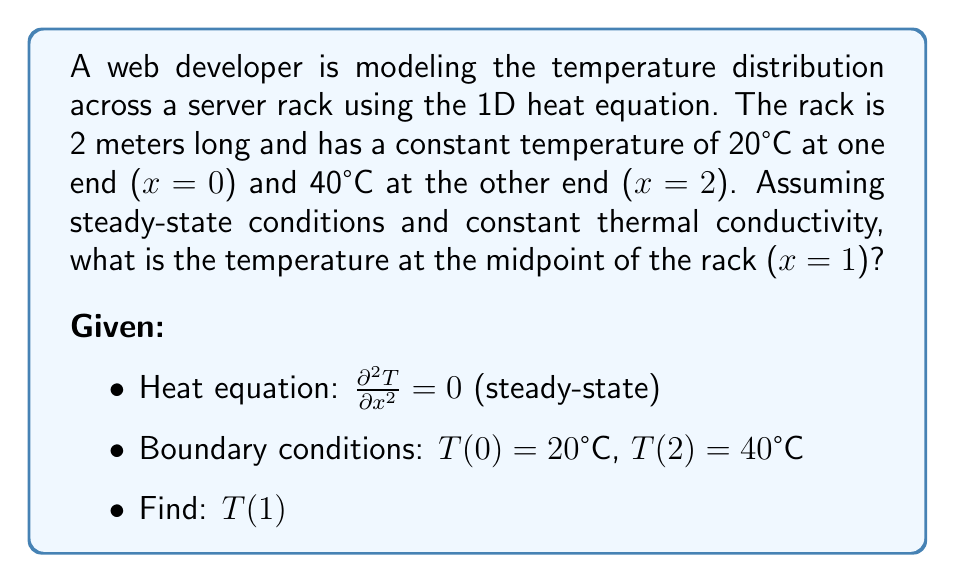Help me with this question. To solve this problem, we'll follow these steps:

1) The general solution to the steady-state heat equation $\frac{\partial^2 T}{\partial x^2} = 0$ is:

   $$T(x) = Ax + B$$

   where A and B are constants we need to determine.

2) Apply the boundary conditions:
   At x = 0: $T(0) = 20 = A(0) + B$, so $B = 20$
   At x = 2: $T(2) = 40 = A(2) + 20$

3) Solve for A:
   $$40 = 2A + 20$$
   $$20 = 2A$$
   $$A = 10$$

4) Our temperature distribution function is now:
   $$T(x) = 10x + 20$$

5) To find the temperature at the midpoint (x = 1), we simply plug in x = 1:
   $$T(1) = 10(1) + 20 = 30$$

Therefore, the temperature at the midpoint of the rack is 30°C.
Answer: 30°C 